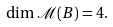<formula> <loc_0><loc_0><loc_500><loc_500>\dim { \mathcal { M } } ( B ) = 4 .</formula> 